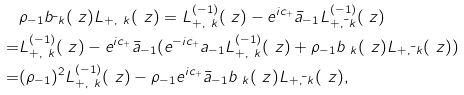<formula> <loc_0><loc_0><loc_500><loc_500>& \rho _ { - 1 } b _ { \bar { \ } k } ( \ z ) L _ { + , \ k } ( \ z ) = L ^ { ( - 1 ) } _ { + , \ k } ( \ z ) - e ^ { i c _ { + } } \bar { a } _ { - 1 } L ^ { ( - 1 ) } _ { + , \bar { \ } k } ( \ z ) \\ = & L ^ { ( - 1 ) } _ { + , \ k } ( \ z ) - e ^ { i c _ { + } } \bar { a } _ { - 1 } ( e ^ { - i c _ { + } } a _ { - 1 } L ^ { ( - 1 ) } _ { + , \ k } ( \ z ) + \rho _ { - 1 } b _ { \ k } ( \ z ) L _ { + , \bar { \ } k } ( \ z ) ) \\ = & ( \rho _ { - 1 } ) ^ { 2 } L ^ { ( - 1 ) } _ { + , \ k } ( \ z ) - \rho _ { - 1 } e ^ { i c _ { + } } \bar { a } _ { - 1 } b _ { \ k } ( \ z ) L _ { + , \bar { \ } k } ( \ z ) ,</formula> 